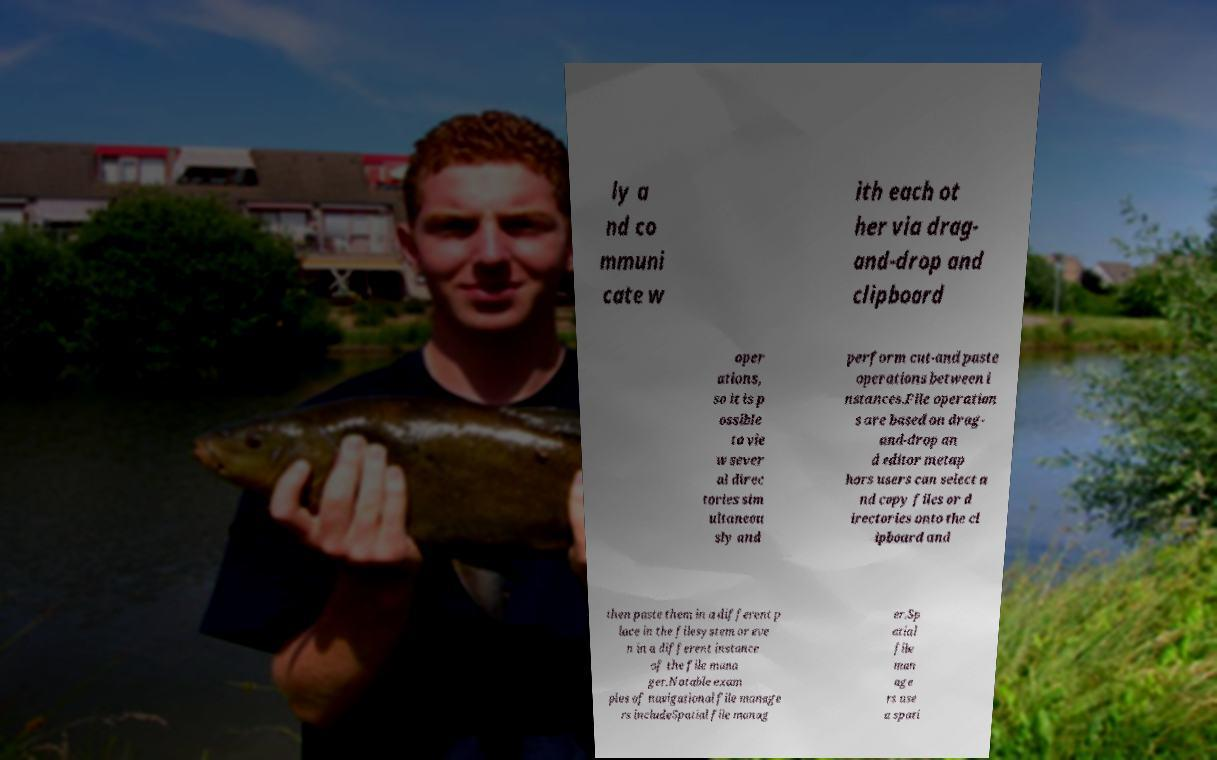Please identify and transcribe the text found in this image. ly a nd co mmuni cate w ith each ot her via drag- and-drop and clipboard oper ations, so it is p ossible to vie w sever al direc tories sim ultaneou sly and perform cut-and paste operations between i nstances.File operation s are based on drag- and-drop an d editor metap hors users can select a nd copy files or d irectories onto the cl ipboard and then paste them in a different p lace in the filesystem or eve n in a different instance of the file mana ger.Notable exam ples of navigational file manage rs includeSpatial file manag er.Sp atial file man age rs use a spati 